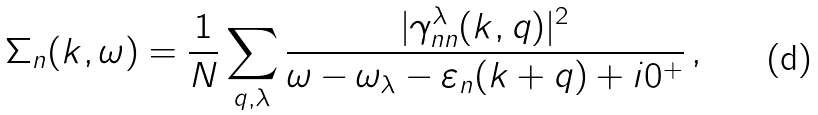Convert formula to latex. <formula><loc_0><loc_0><loc_500><loc_500>\Sigma _ { n } ( k , \omega ) = \frac { 1 } { N } \sum _ { q , \lambda } \frac { | \gamma _ { n n } ^ { \lambda } ( k , q ) | ^ { 2 } } { \omega - \omega _ { \lambda } - \varepsilon _ { n } ( k + q ) + i 0 ^ { + } } \, ,</formula> 